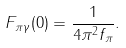<formula> <loc_0><loc_0><loc_500><loc_500>F _ { \pi \gamma } ( 0 ) = \frac { 1 } { 4 \pi ^ { 2 } f _ { \pi } } .</formula> 